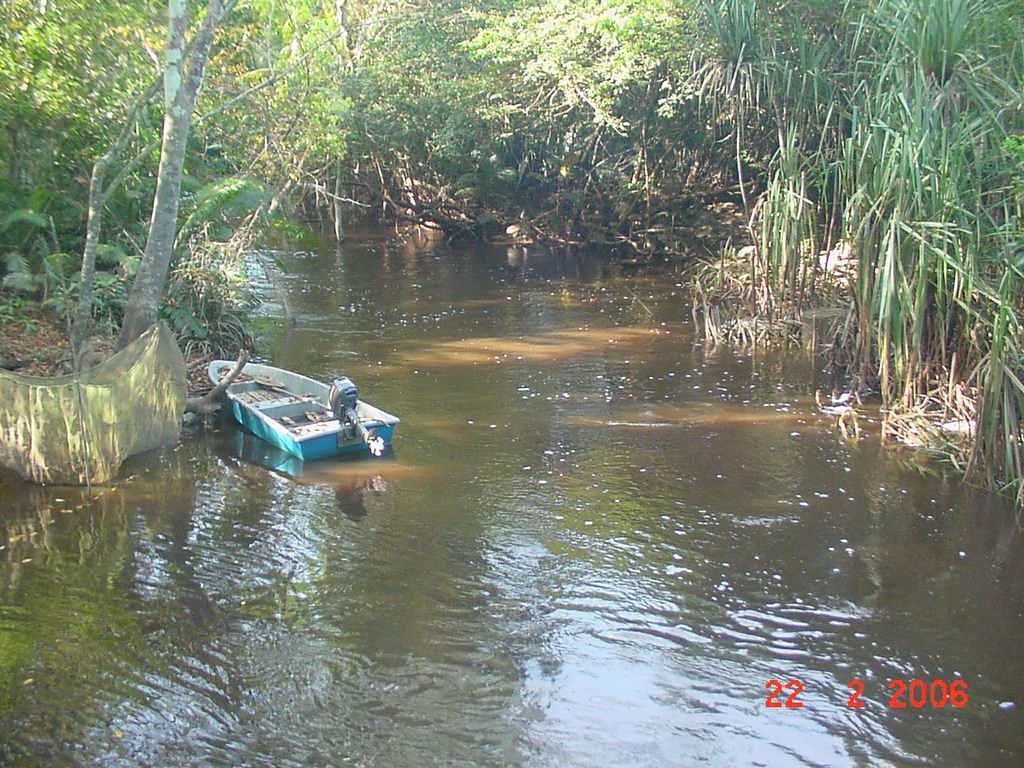Could you give a brief overview of what you see in this image? There is a river. On the river side there is a boat. On the sides of the river there are many trees. And there is a watermark on the right corner. 